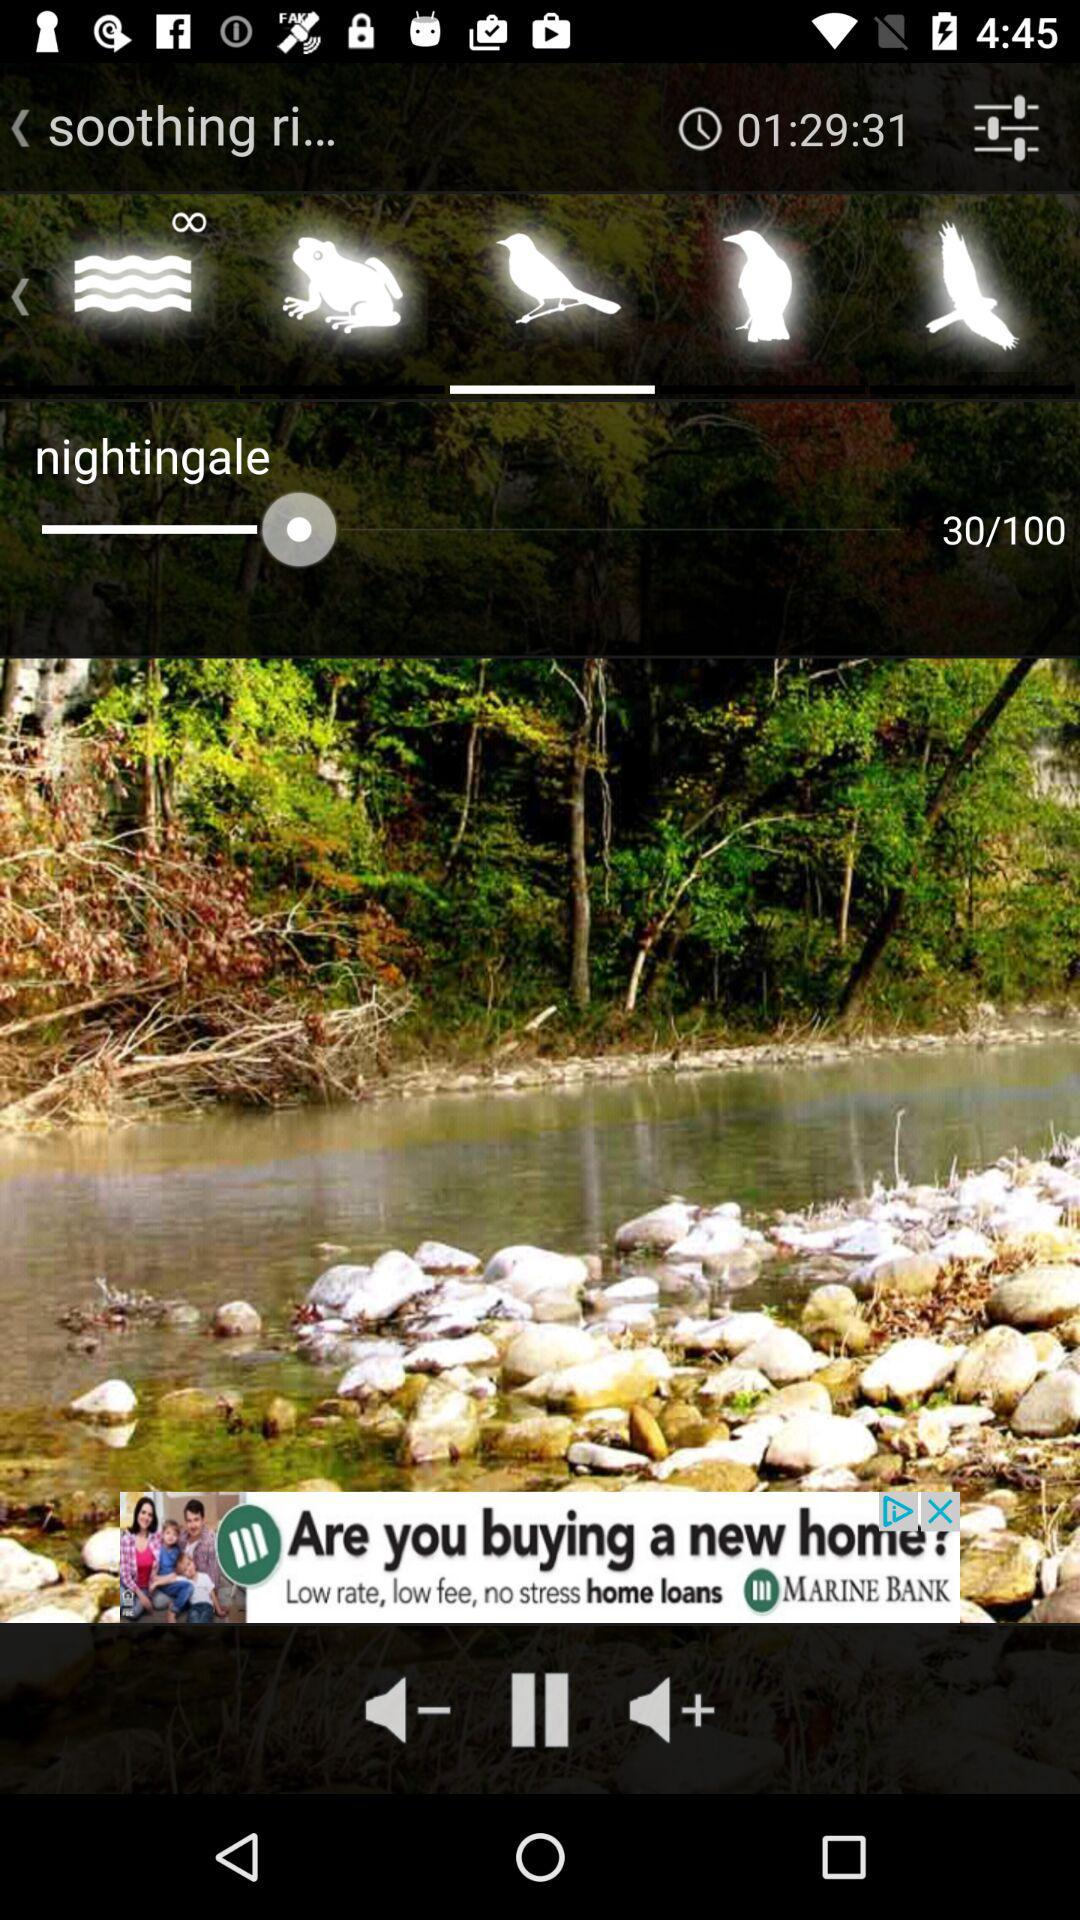What is the set volume of the ringtone "nightingale"? The set volume of the ringtone is 30. 